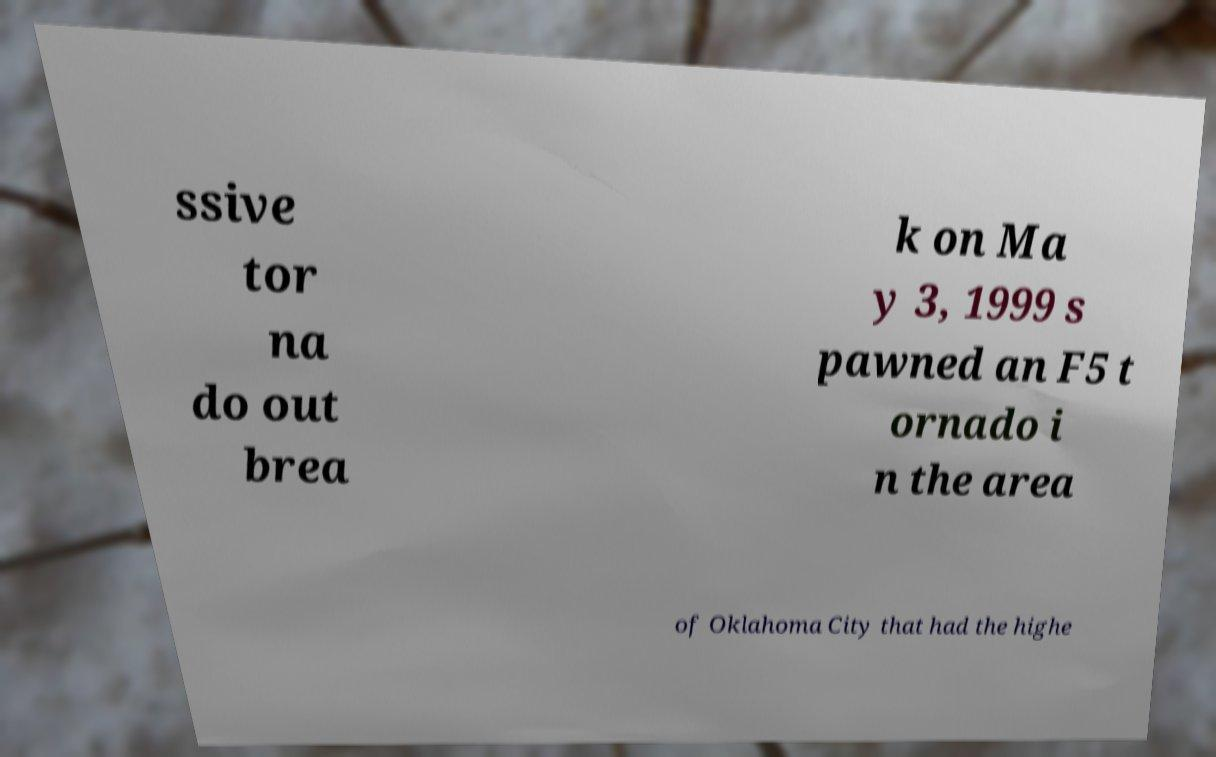Please read and relay the text visible in this image. What does it say? ssive tor na do out brea k on Ma y 3, 1999 s pawned an F5 t ornado i n the area of Oklahoma City that had the highe 